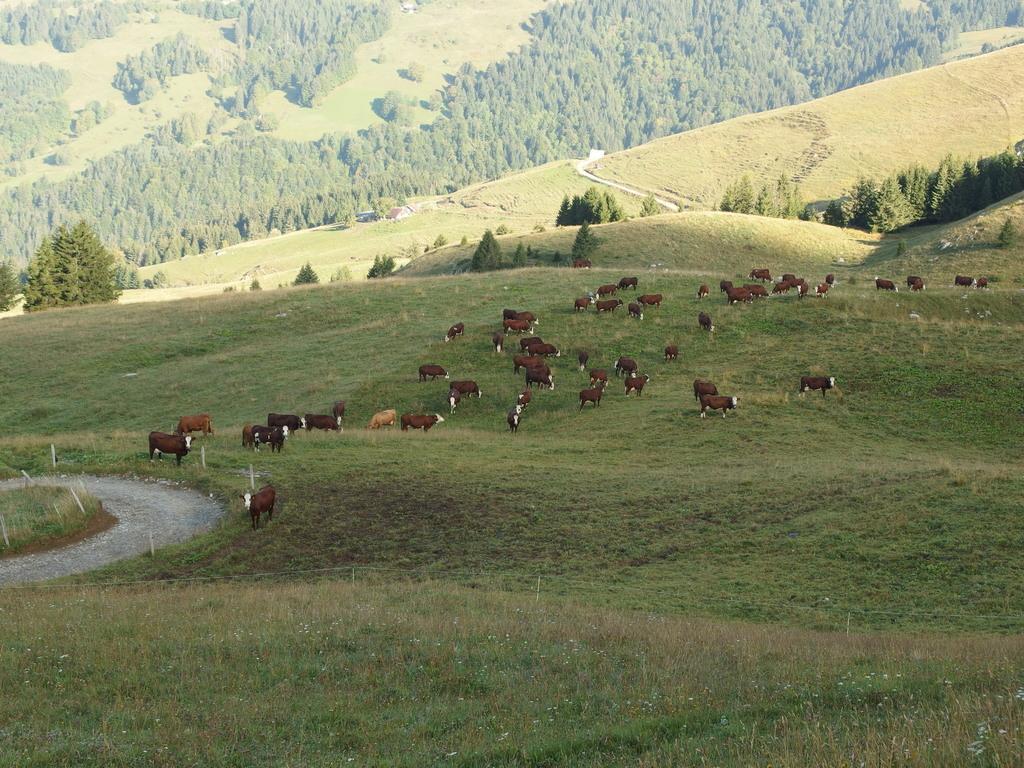How would you summarize this image in a sentence or two? A herd of sheep grazing, in the left side there are trees. 